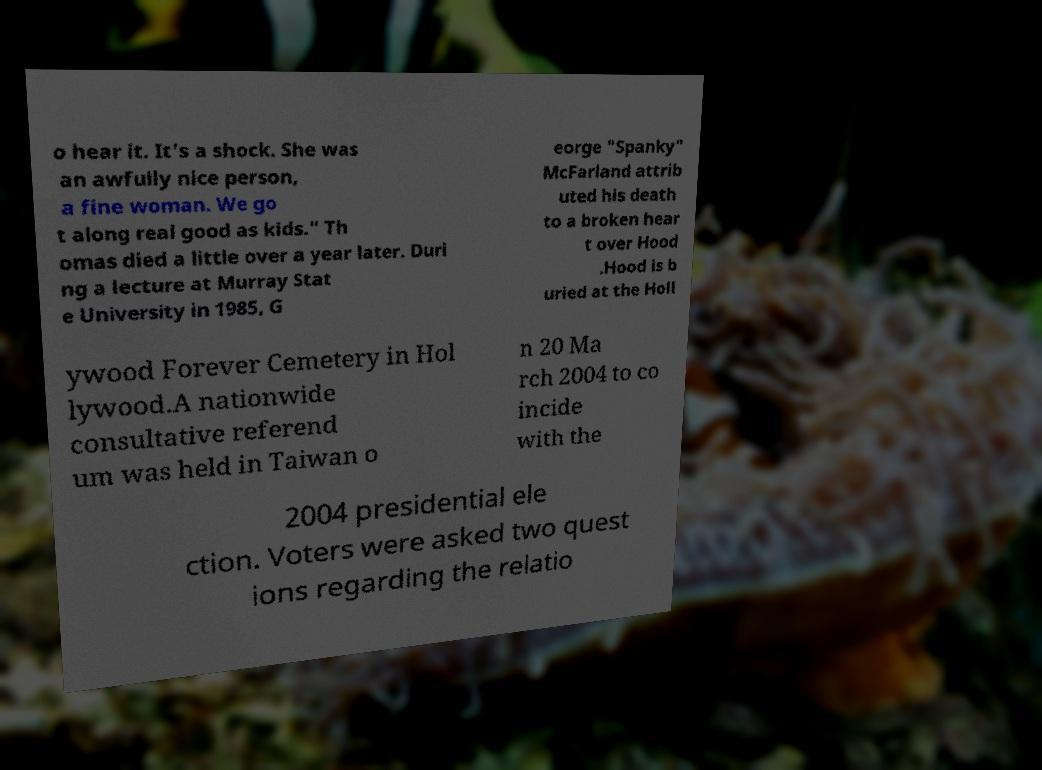What messages or text are displayed in this image? I need them in a readable, typed format. o hear it. It's a shock. She was an awfully nice person, a fine woman. We go t along real good as kids." Th omas died a little over a year later. Duri ng a lecture at Murray Stat e University in 1985, G eorge "Spanky" McFarland attrib uted his death to a broken hear t over Hood .Hood is b uried at the Holl ywood Forever Cemetery in Hol lywood.A nationwide consultative referend um was held in Taiwan o n 20 Ma rch 2004 to co incide with the 2004 presidential ele ction. Voters were asked two quest ions regarding the relatio 